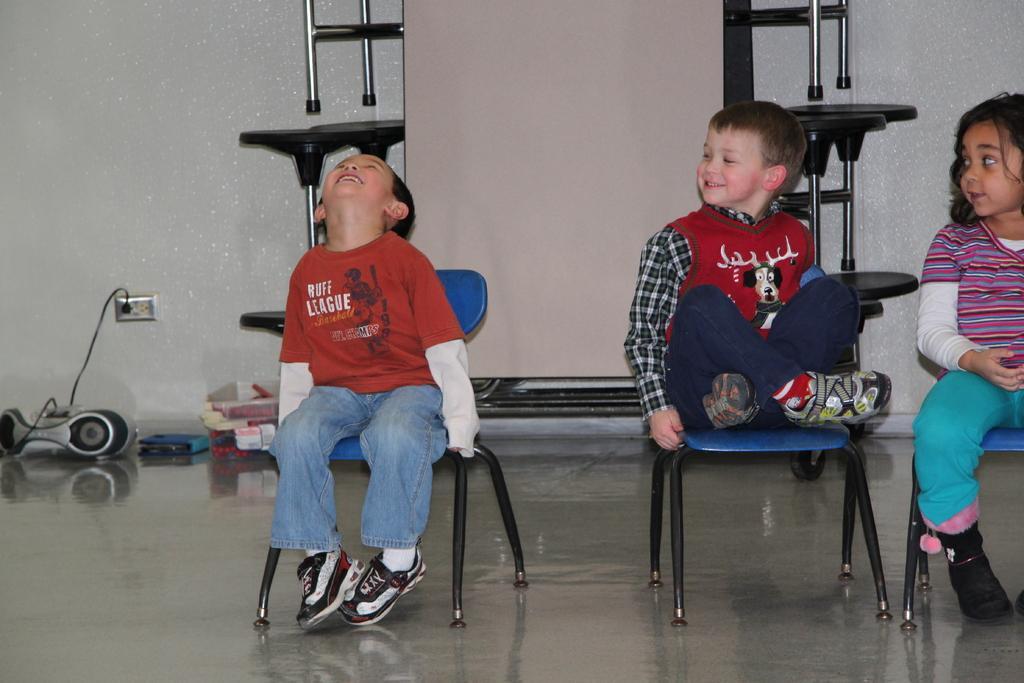Please provide a concise description of this image. In this picture we see two boys and one girl seated on the chairs. with a smile on their faces 